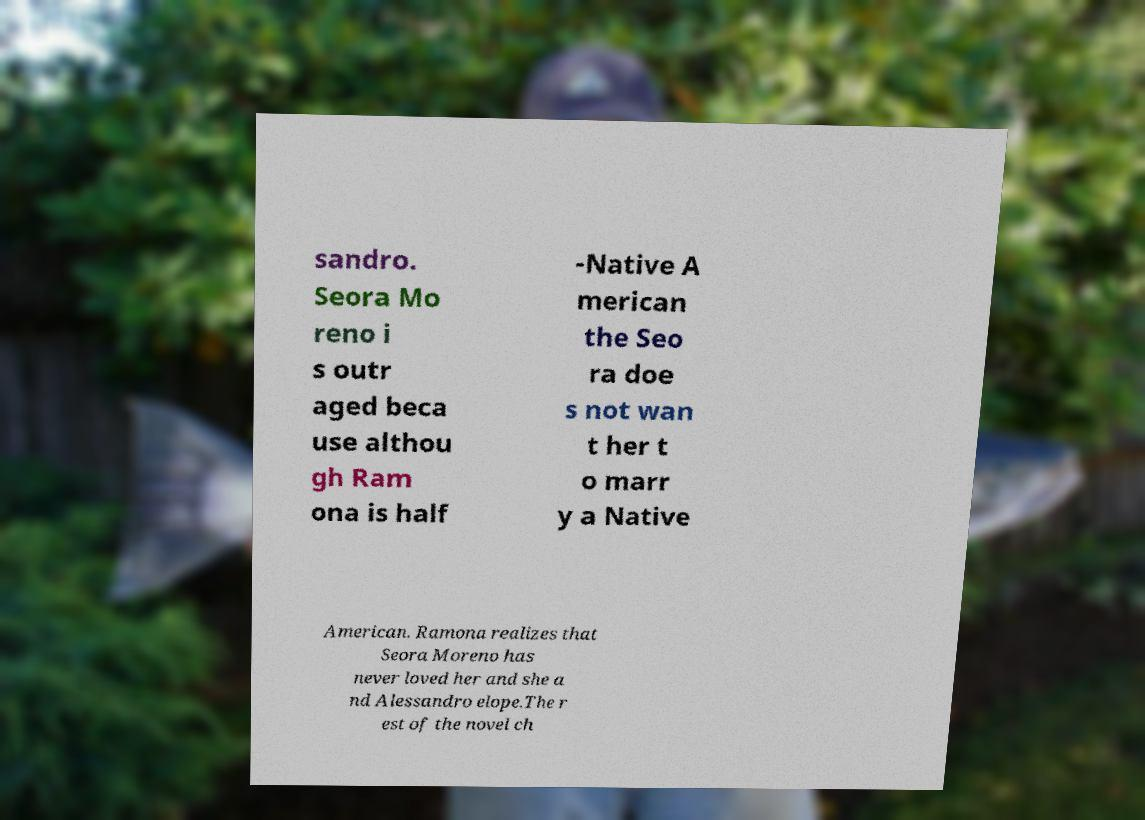What messages or text are displayed in this image? I need them in a readable, typed format. sandro. Seora Mo reno i s outr aged beca use althou gh Ram ona is half -Native A merican the Seo ra doe s not wan t her t o marr y a Native American. Ramona realizes that Seora Moreno has never loved her and she a nd Alessandro elope.The r est of the novel ch 